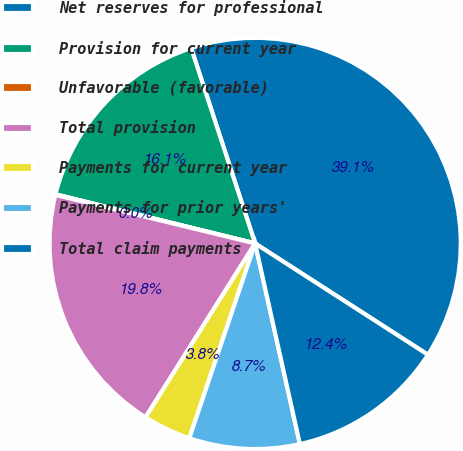Convert chart to OTSL. <chart><loc_0><loc_0><loc_500><loc_500><pie_chart><fcel>Net reserves for professional<fcel>Provision for current year<fcel>Unfavorable (favorable)<fcel>Total provision<fcel>Payments for current year<fcel>Payments for prior years'<fcel>Total claim payments<nl><fcel>39.15%<fcel>16.12%<fcel>0.05%<fcel>19.84%<fcel>3.77%<fcel>8.68%<fcel>12.4%<nl></chart> 